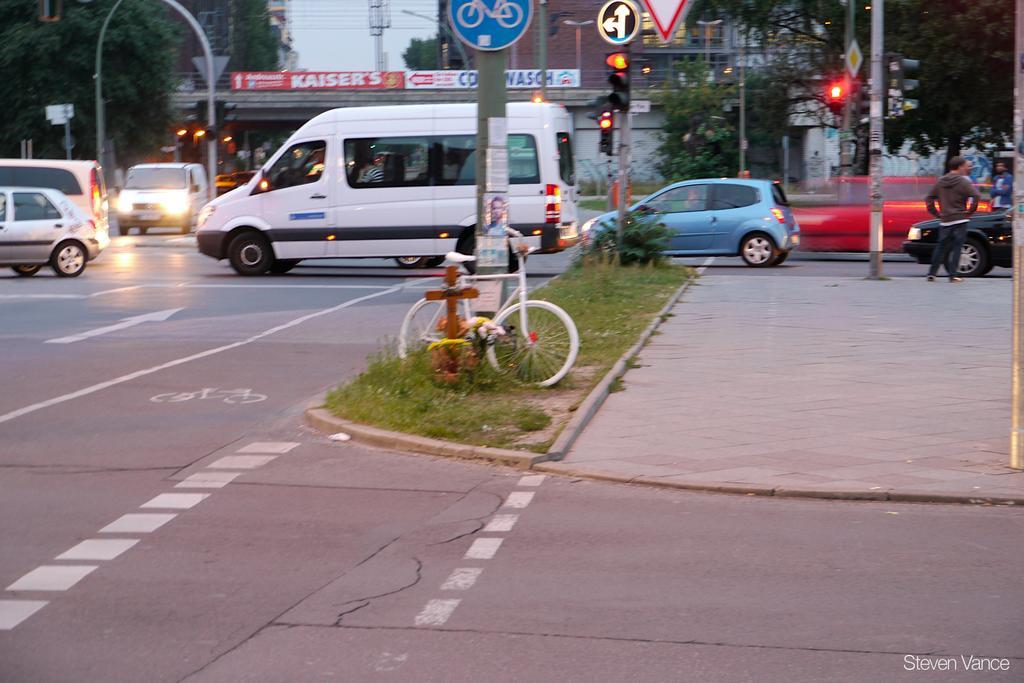In one or two sentences, can you explain what this image depicts? In this picture I can see there is a road and there are few vehicles moving on the road and there are some poles and there is a bicycle at the pole and there is a bridge in the backdrop, there are some buildings and the sky is clear. 